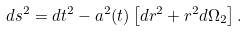<formula> <loc_0><loc_0><loc_500><loc_500>d s ^ { 2 } = d t ^ { 2 } - a ^ { 2 } ( t ) \left [ d r ^ { 2 } + r ^ { 2 } d \Omega _ { 2 } \right ] .</formula> 